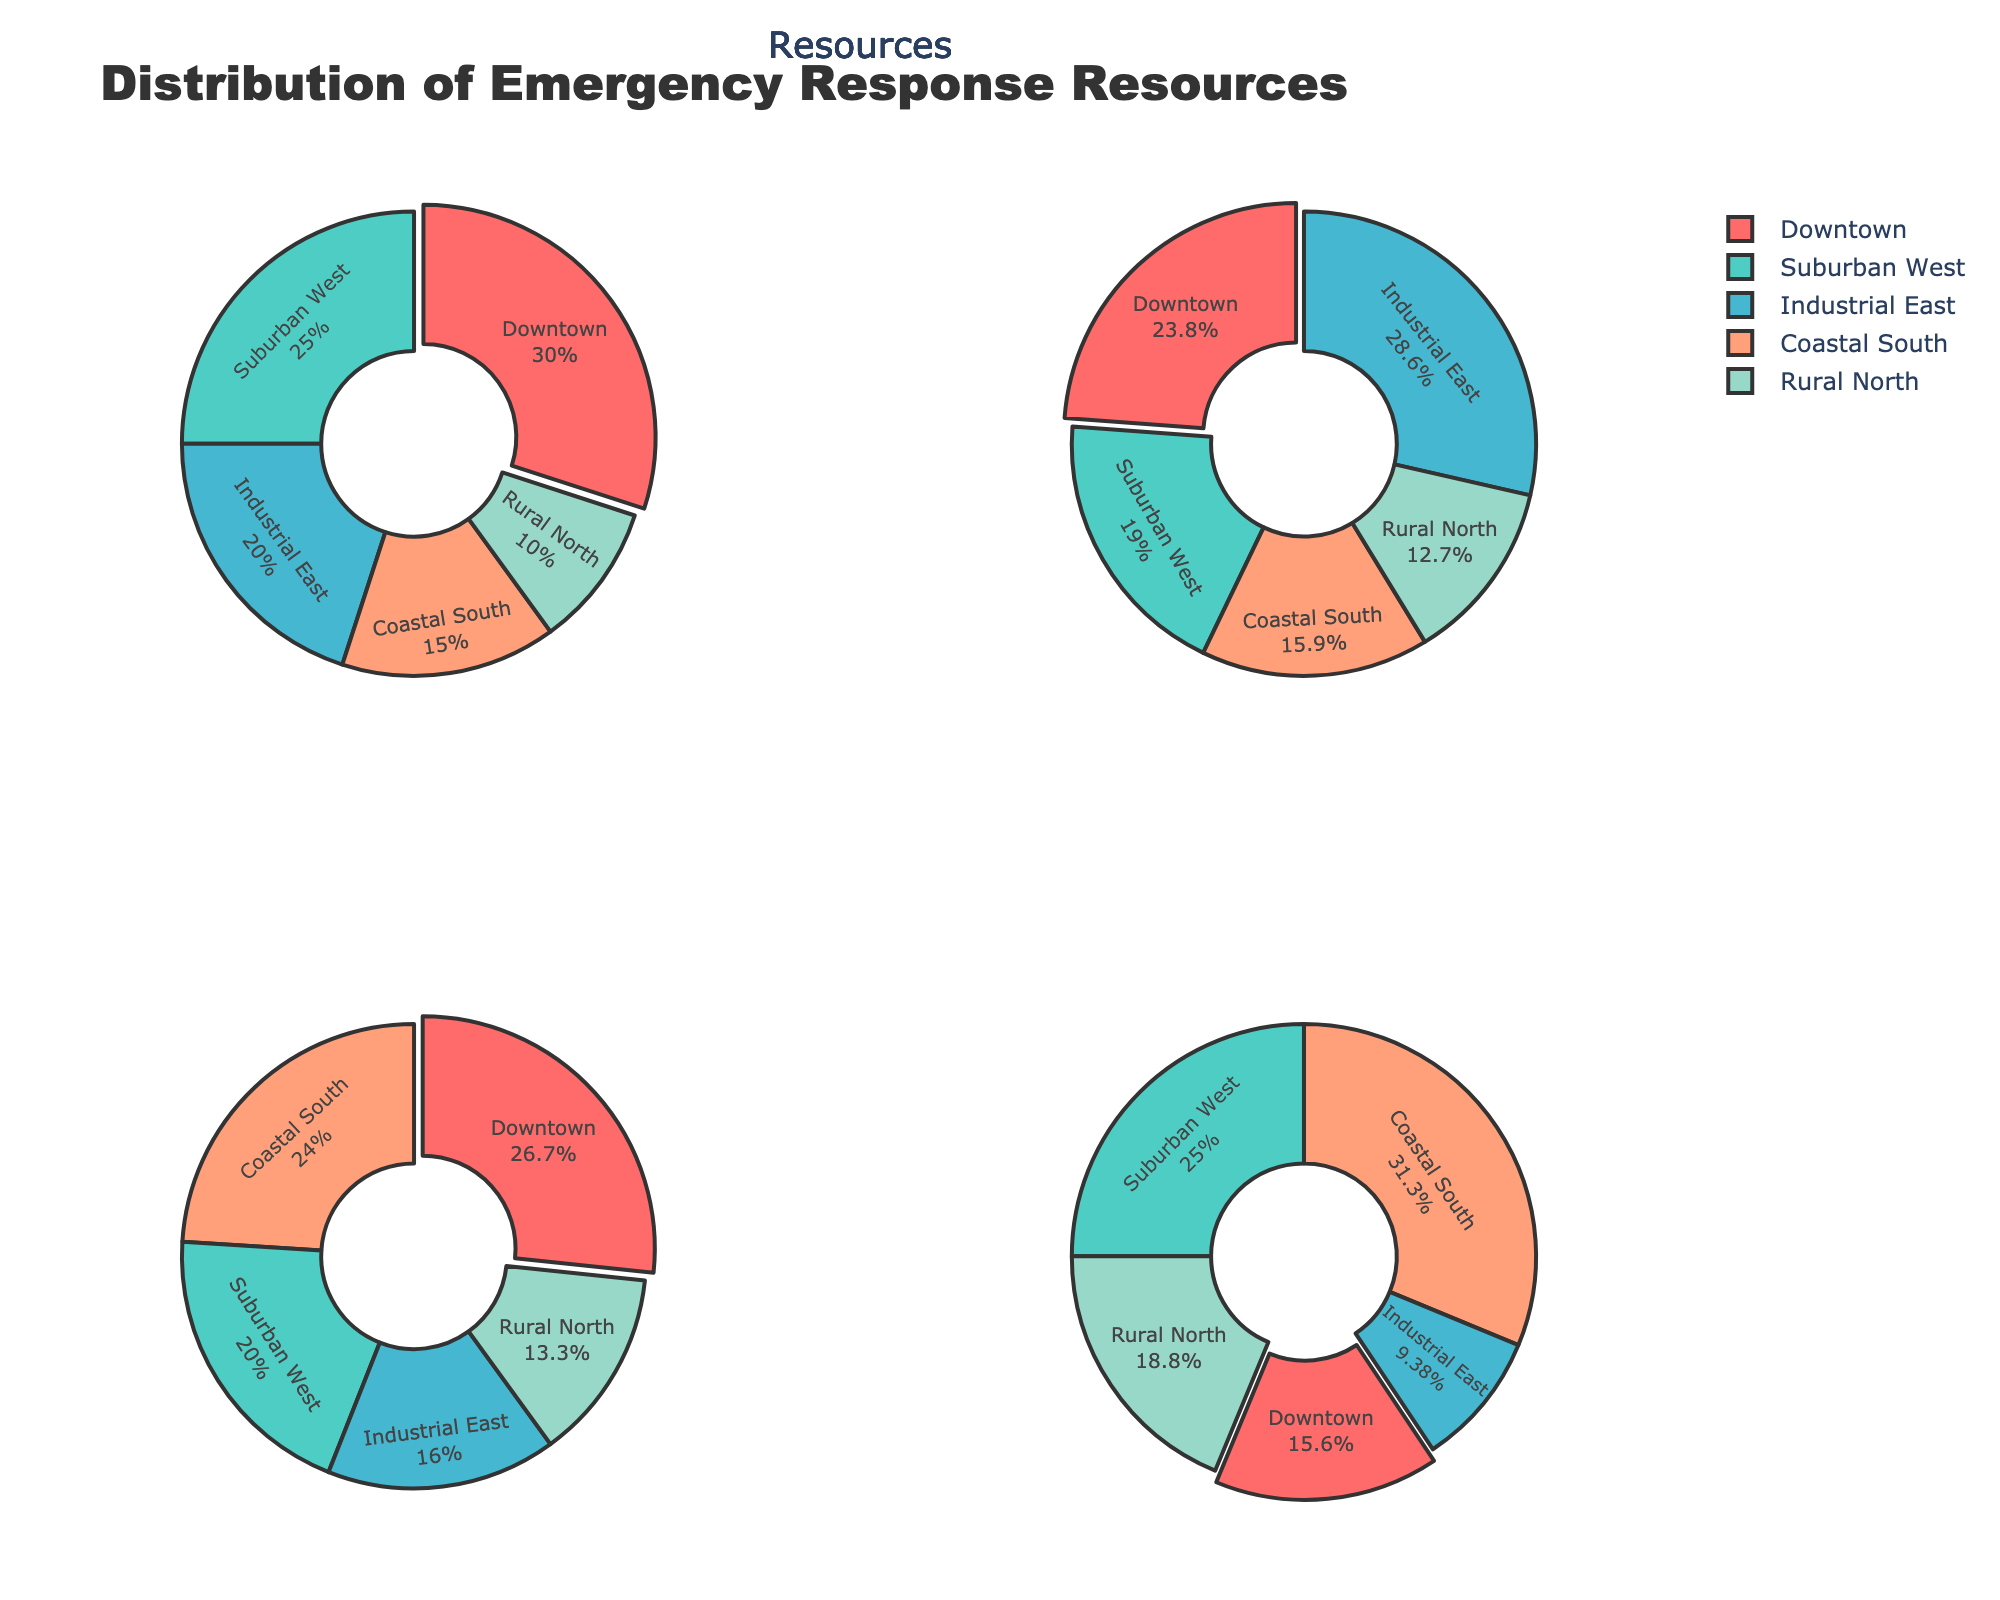What's the title of the figure? The title is usually presented at the top of the figure. It provides a summary of the visual information.
Answer: Distribution of Emergency Response Resources How many districts are there in the figure? Each pie chart segment represents a different district. By counting the slices, we can determine the number of districts.
Answer: 5 Which district has the highest percentage of Police Units? By looking at the Police Units pie chart, we can identify the largest slice, which indicates the district with the highest percentage of Police Units.
Answer: Downtown How many types of resources are compared in the figure? The figure contains multiple pie charts, each representing a different type of resource. By counting these charts, we can determine the number of resource types.
Answer: 4 Which district has the smallest percentage of Fire Trucks? In the Fire Trucks pie chart, the smallest slice corresponds to the district with the lowest percentage of Fire Trucks.
Answer: Rural North Which district has the most Emergency Shelters? The pie chart for Emergency Shelters shows the distribution of shelters across districts. The largest slice indicates the district with the most shelters.
Answer: Coastal South Do any two districts have the same percentage of Ambulances? By examining the Ambulances pie chart, we can compare the sizes of the slices to see if any two districts share the same percentage.
Answer: No Which resource type has the smallest slice for Downtown? By comparing the Downtown segments across all pie charts, we can identify which resource type has the smallest percentage.
Answer: Emergency Shelters What is the percentage of Ambulances allocated to the Suburban West district? The Ambulances pie chart displays the distribution. We find the slice corresponding to Suburban West and read off the percentage.
Answer: 25% How do Police Units compare between Coastal South and Rural North? We look at the Police Units pie chart and compare the sizes of the slices for Coastal South and Rural North to see which is larger.
Answer: Coastal South has more 